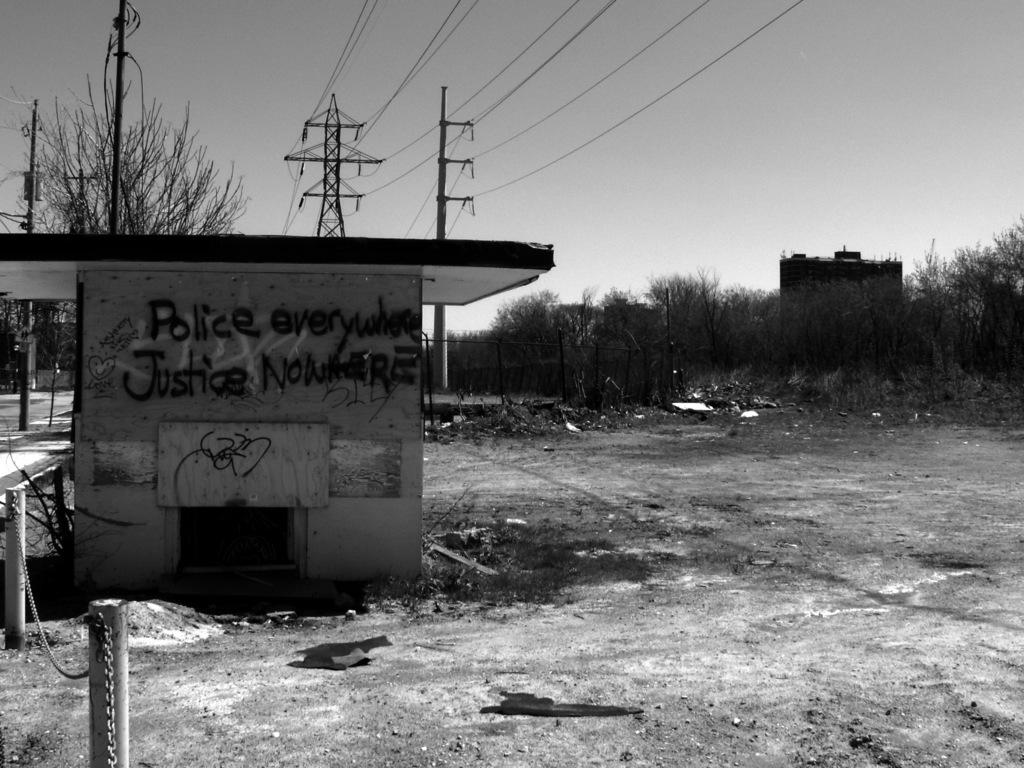What type of structures can be seen in the image? There are buildings in the image. What else can be seen in the image besides buildings? There are poles, wires, trees, and a fence in the image. What is visible in the background of the image? The sky is visible in the background of the image. How does the land express anger in the image? There is no expression of anger by the land in the image, as it is a still image of buildings, poles, wires, trees, a fence, and the sky. What type of debt is associated with the buildings in the image? There is no information about debt associated with the buildings in the image. 